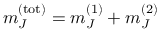Convert formula to latex. <formula><loc_0><loc_0><loc_500><loc_500>m _ { J } ^ { ( t o t ) } = m _ { J } ^ { ( 1 ) } + m _ { J } ^ { ( 2 ) }</formula> 